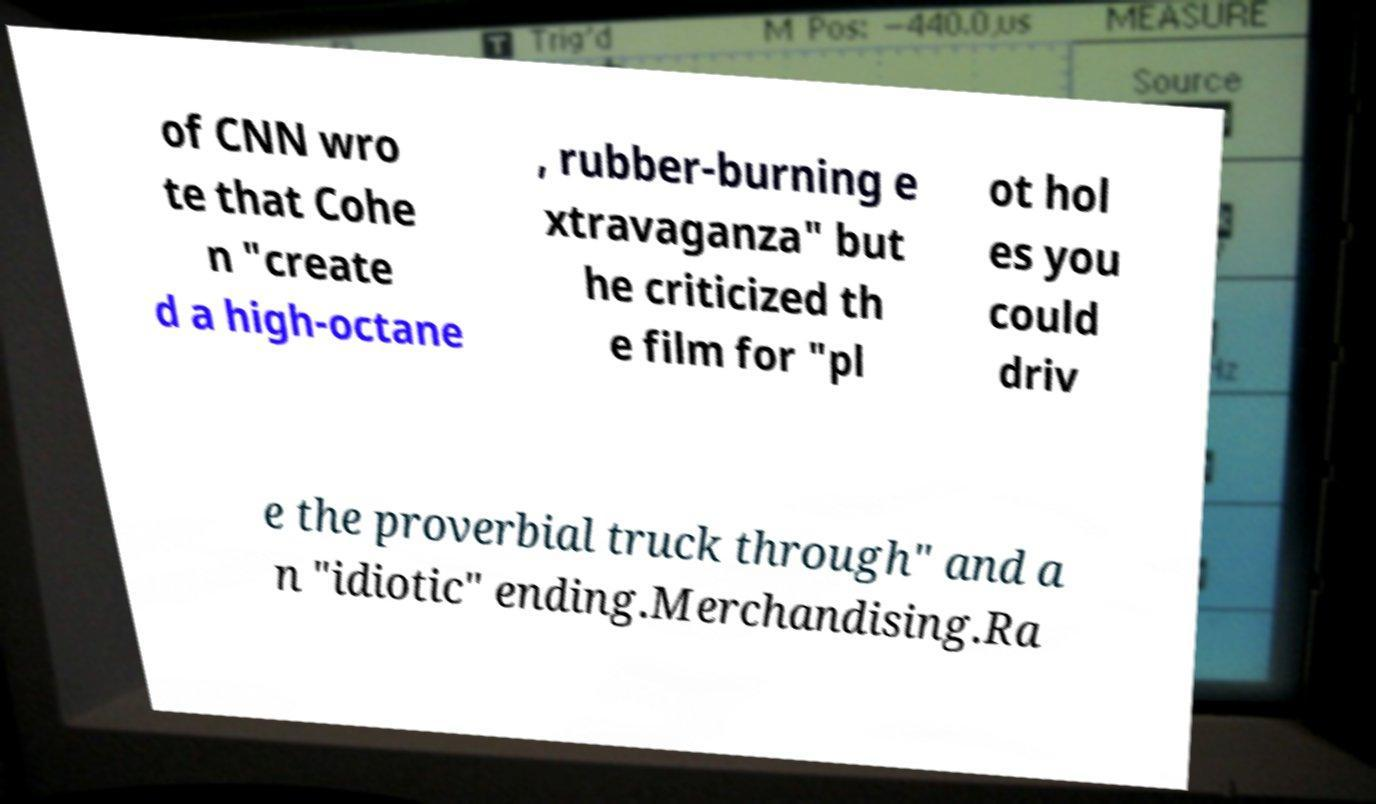There's text embedded in this image that I need extracted. Can you transcribe it verbatim? of CNN wro te that Cohe n "create d a high-octane , rubber-burning e xtravaganza" but he criticized th e film for "pl ot hol es you could driv e the proverbial truck through" and a n "idiotic" ending.Merchandising.Ra 